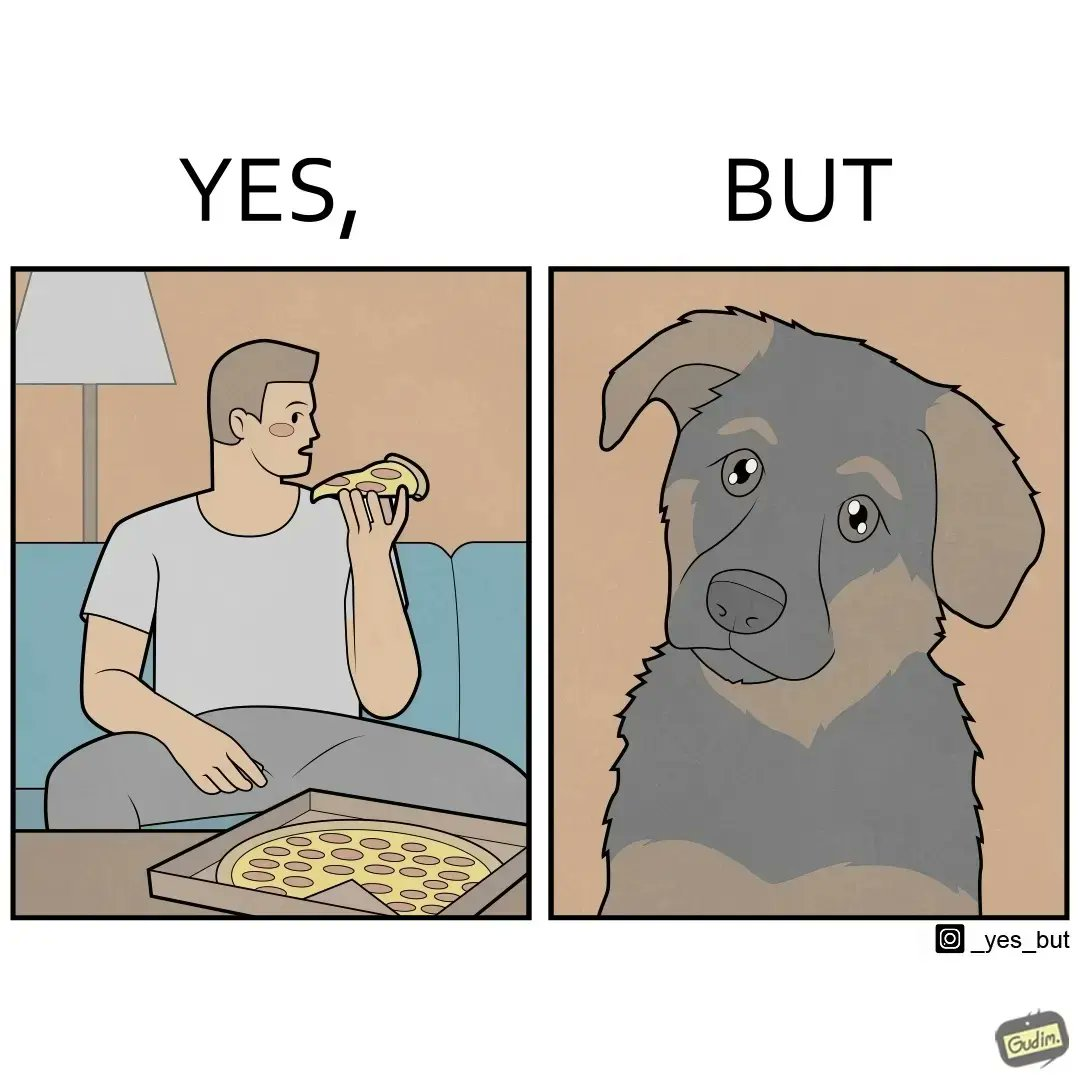Is this a satirical image? Yes, this image is satirical. 